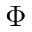<formula> <loc_0><loc_0><loc_500><loc_500>\Phi</formula> 